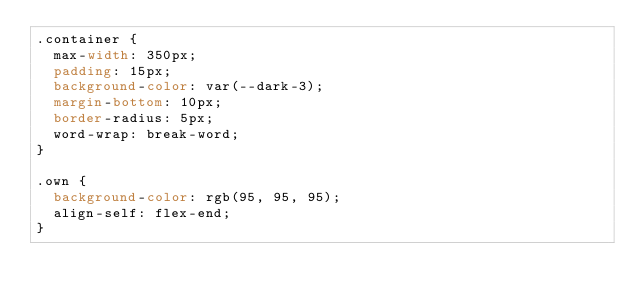<code> <loc_0><loc_0><loc_500><loc_500><_CSS_>.container {
  max-width: 350px;
  padding: 15px;
  background-color: var(--dark-3);
  margin-bottom: 10px;
  border-radius: 5px;
  word-wrap: break-word;
}

.own {
  background-color: rgb(95, 95, 95);
  align-self: flex-end;
}</code> 